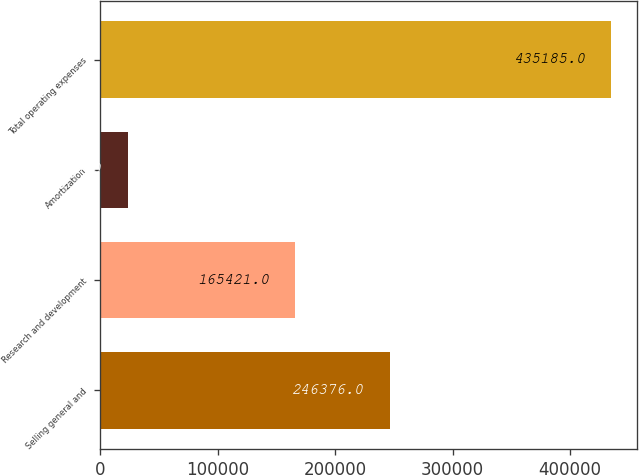Convert chart. <chart><loc_0><loc_0><loc_500><loc_500><bar_chart><fcel>Selling general and<fcel>Research and development<fcel>Amortization<fcel>Total operating expenses<nl><fcel>246376<fcel>165421<fcel>23388<fcel>435185<nl></chart> 